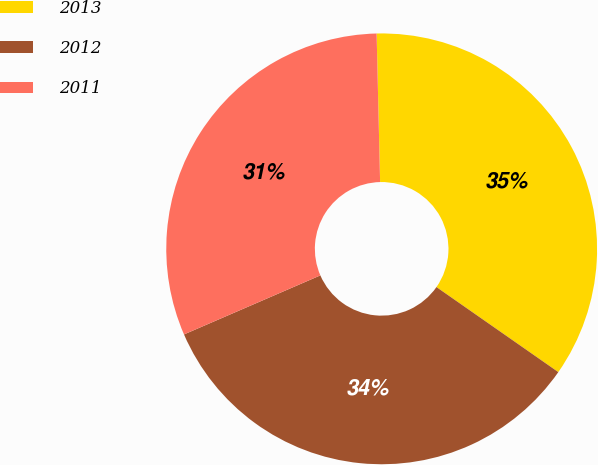<chart> <loc_0><loc_0><loc_500><loc_500><pie_chart><fcel>2013<fcel>2012<fcel>2011<nl><fcel>35.07%<fcel>33.8%<fcel>31.13%<nl></chart> 